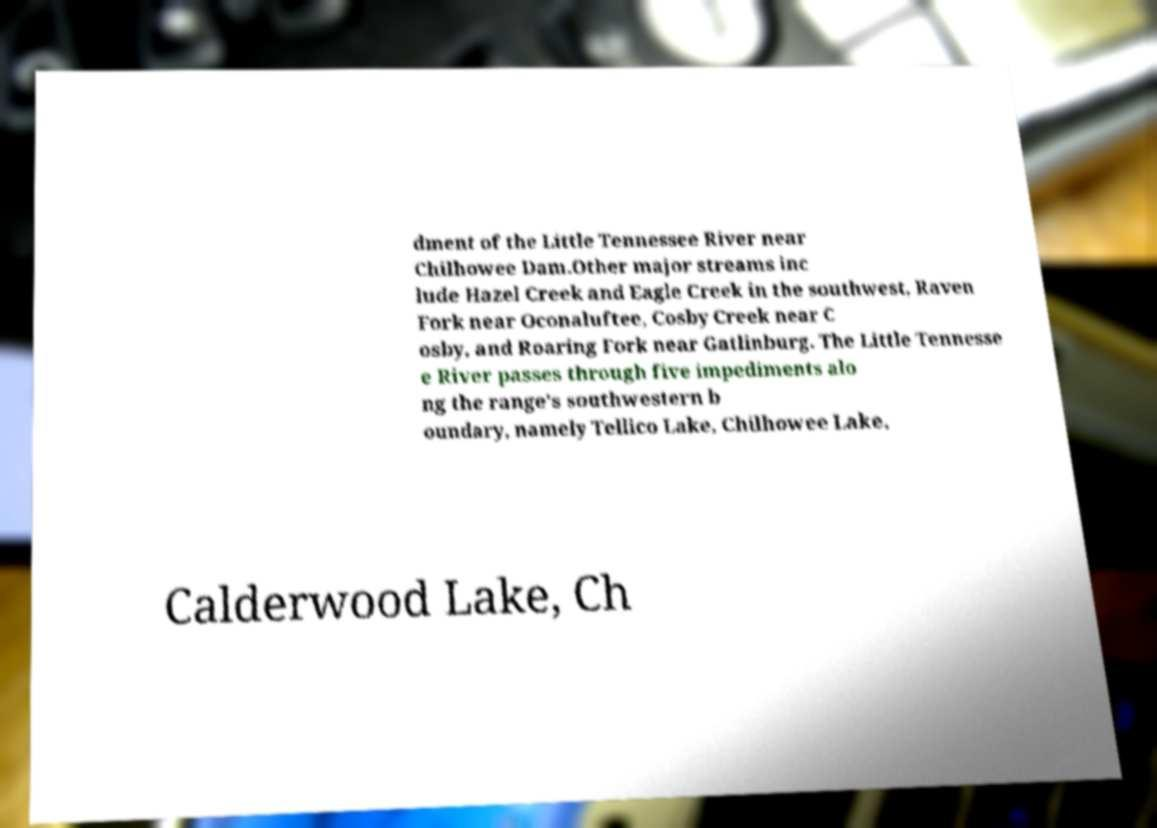I need the written content from this picture converted into text. Can you do that? dment of the Little Tennessee River near Chilhowee Dam.Other major streams inc lude Hazel Creek and Eagle Creek in the southwest, Raven Fork near Oconaluftee, Cosby Creek near C osby, and Roaring Fork near Gatlinburg. The Little Tennesse e River passes through five impediments alo ng the range's southwestern b oundary, namely Tellico Lake, Chilhowee Lake, Calderwood Lake, Ch 